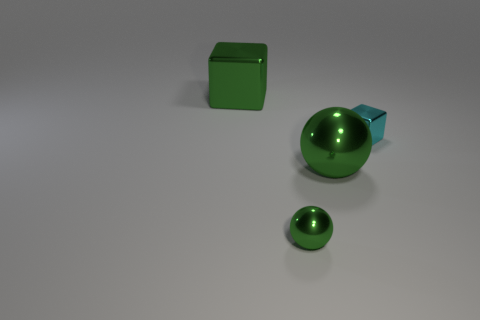Subtract all brown spheres. Subtract all green blocks. How many spheres are left? 2 Subtract all brown blocks. How many purple spheres are left? 0 Add 2 cyans. How many tiny objects exist? 0 Subtract all cyan metal blocks. Subtract all small blue metal cylinders. How many objects are left? 3 Add 1 green metallic cubes. How many green metallic cubes are left? 2 Add 2 green spheres. How many green spheres exist? 4 Add 2 metal objects. How many objects exist? 6 Subtract all green cubes. How many cubes are left? 1 Subtract 0 yellow cylinders. How many objects are left? 4 Subtract 1 spheres. How many spheres are left? 1 